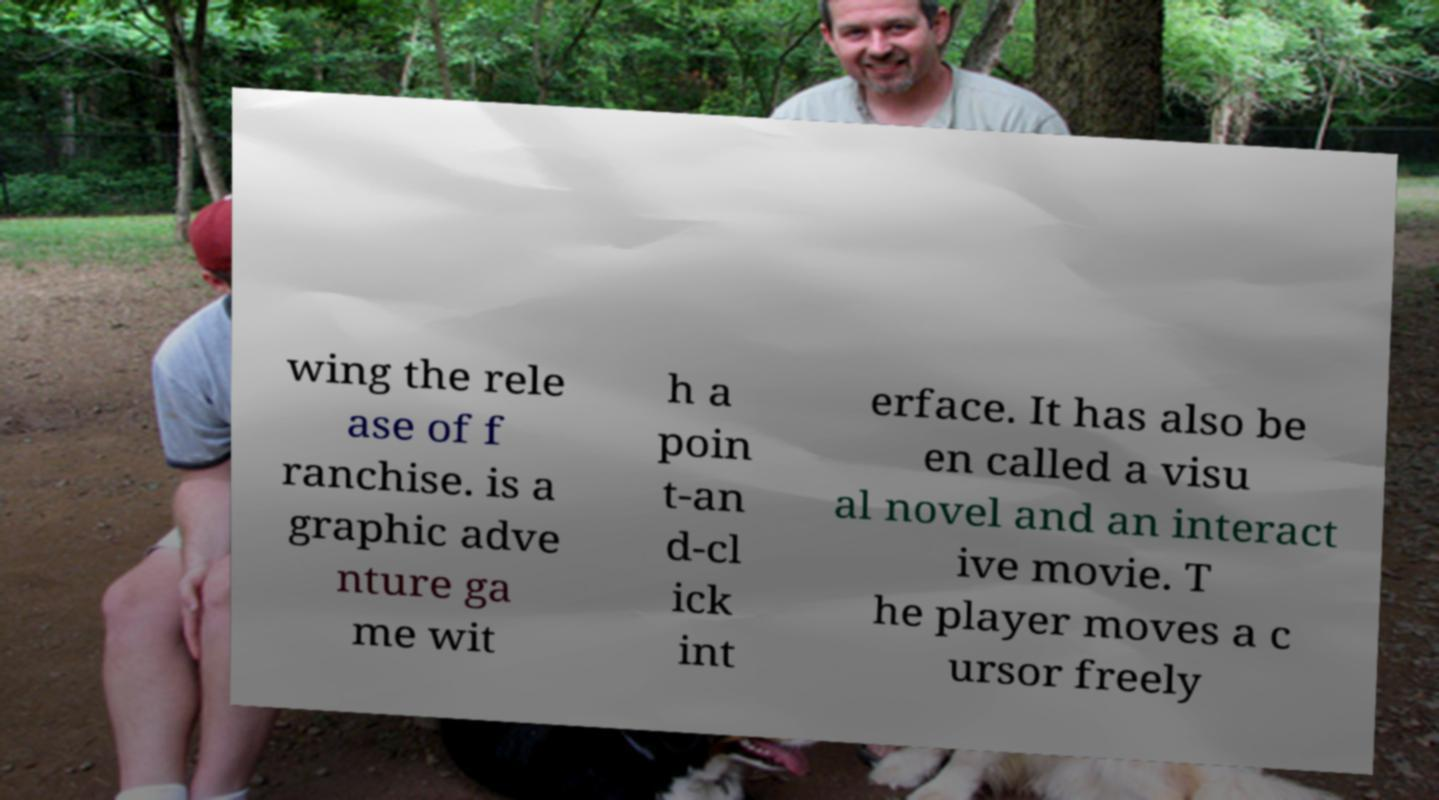Can you accurately transcribe the text from the provided image for me? wing the rele ase of f ranchise. is a graphic adve nture ga me wit h a poin t-an d-cl ick int erface. It has also be en called a visu al novel and an interact ive movie. T he player moves a c ursor freely 